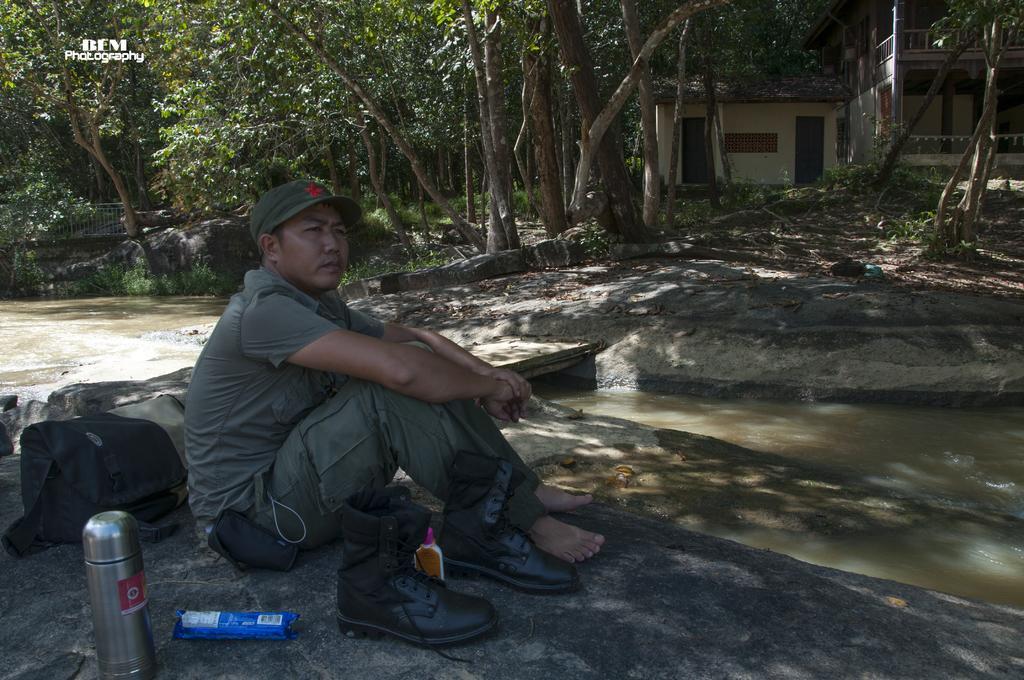Could you give a brief overview of what you see in this image? In this image we can see a man sitting on the rock. Beside him there are packaged food, a pair of shoes, bags and a thermos flask. In the background there are buildings, trees, rocks, grass, bridge and running water. 